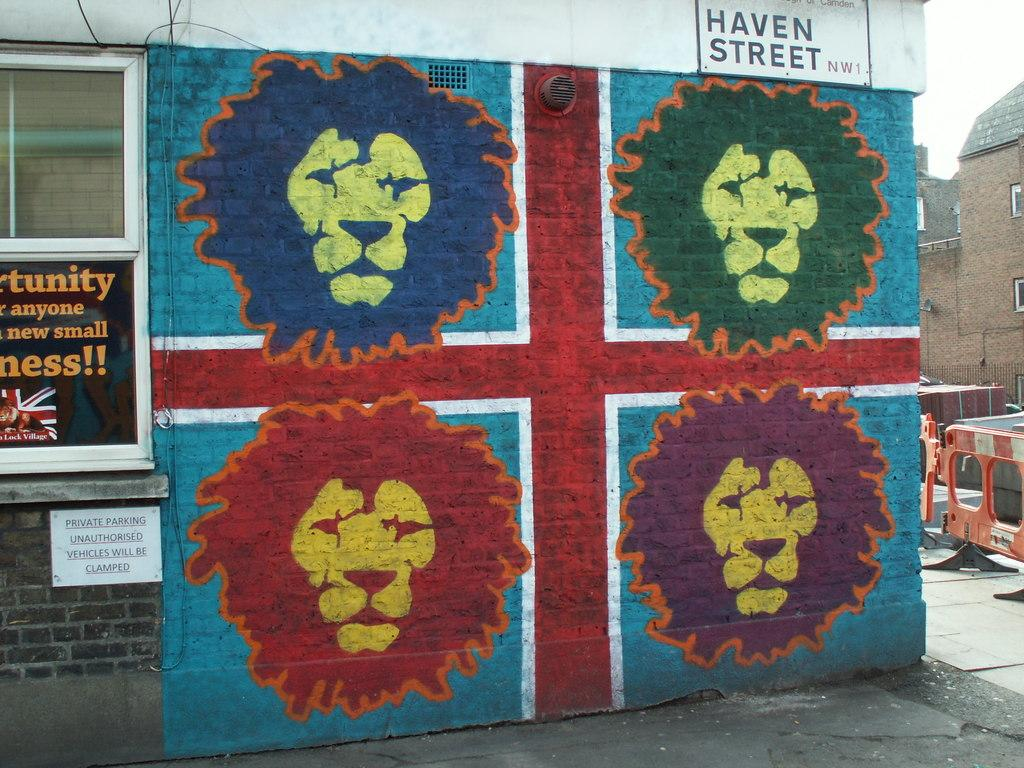<image>
Create a compact narrative representing the image presented. a lion painting with Haven Street above it 